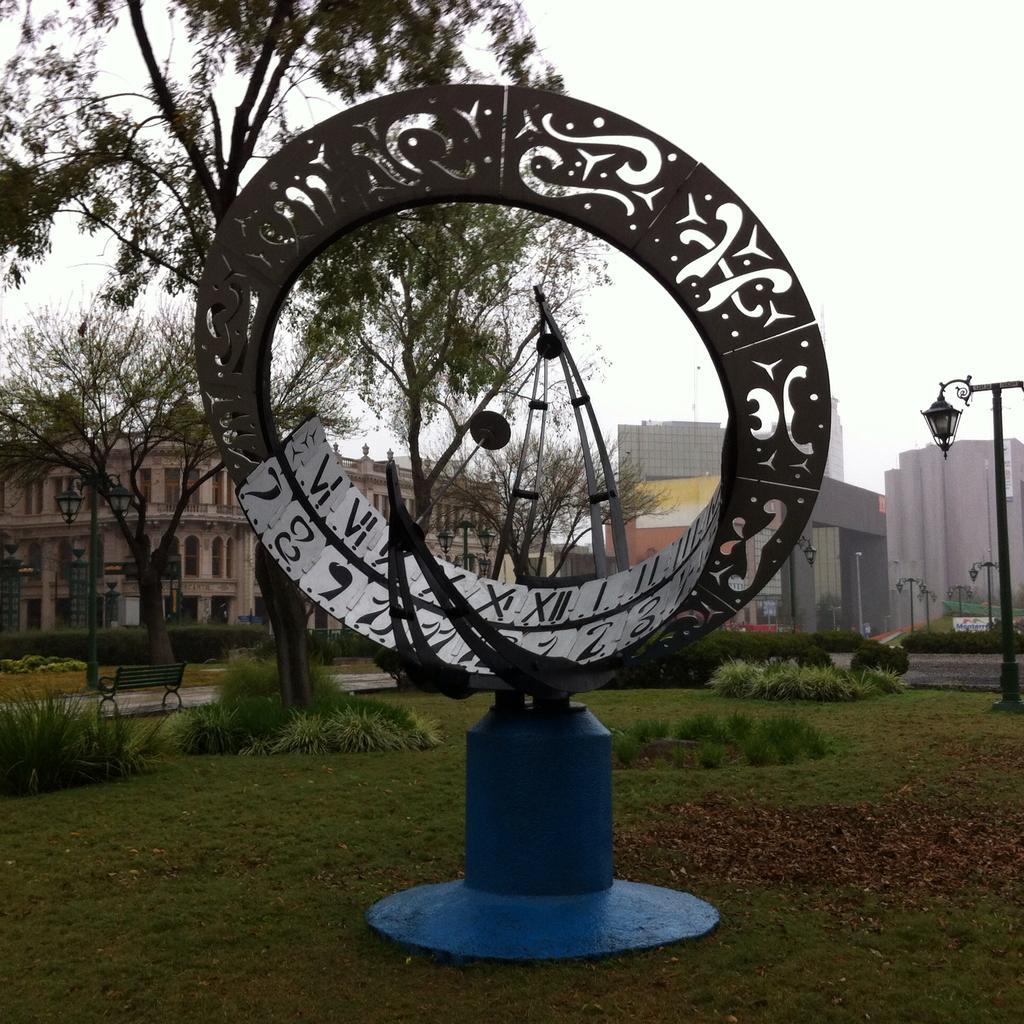Describe this image in one or two sentences. In the foreground of this picture, there is a statue on the grass. In the background, there are trees, plants, grass, a pole, buildings, and the sky. 